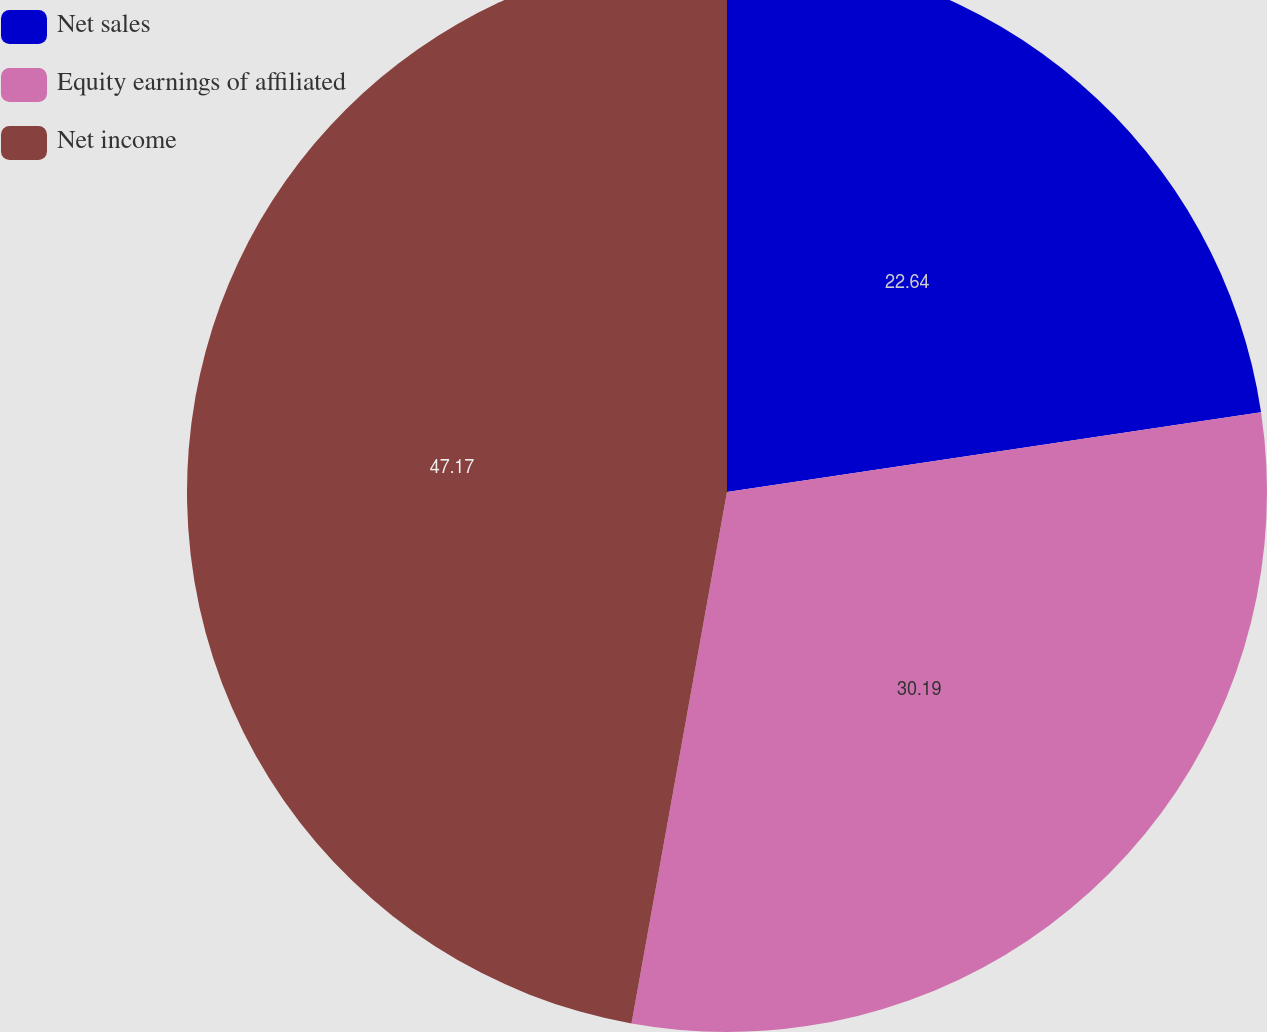<chart> <loc_0><loc_0><loc_500><loc_500><pie_chart><fcel>Net sales<fcel>Equity earnings of affiliated<fcel>Net income<nl><fcel>22.64%<fcel>30.19%<fcel>47.17%<nl></chart> 